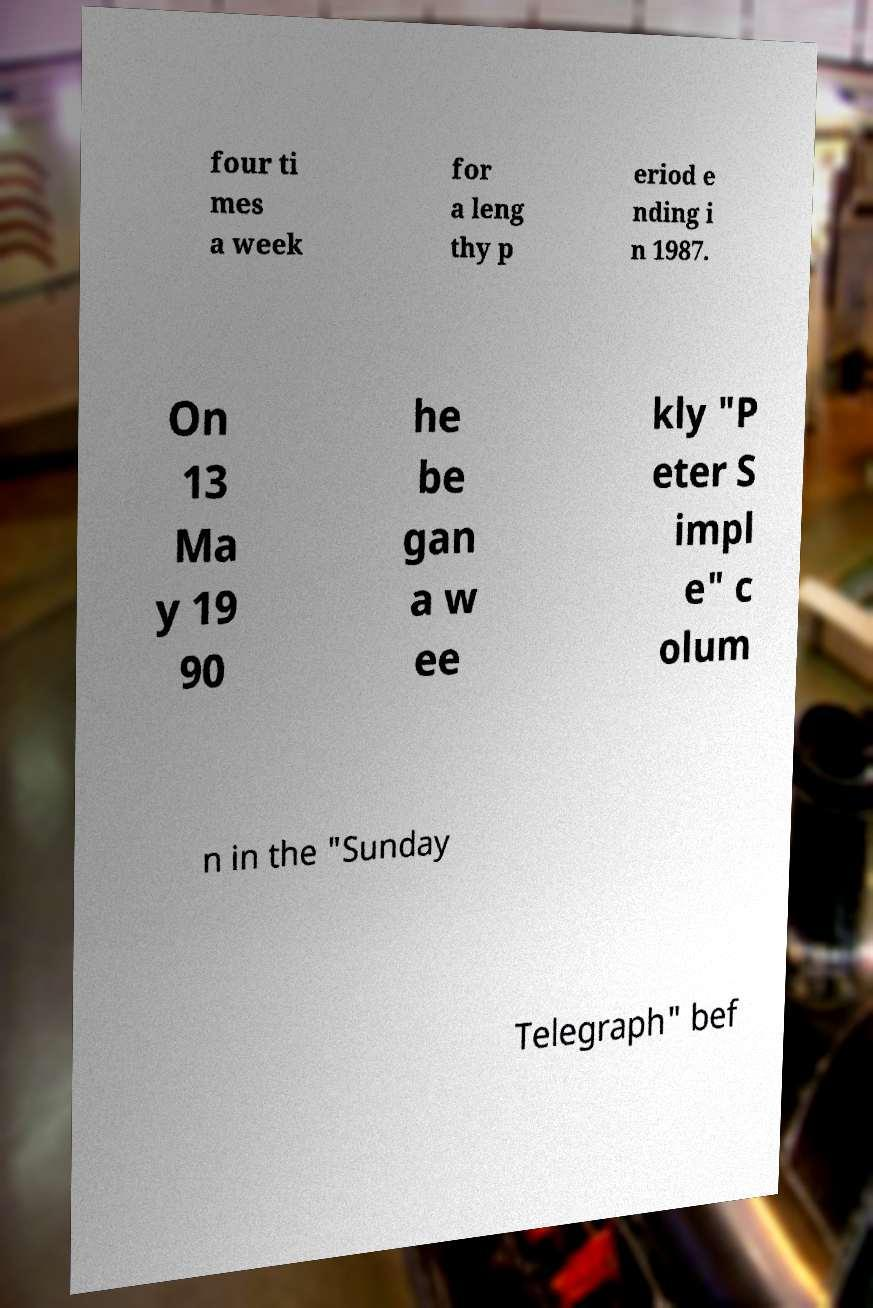Can you accurately transcribe the text from the provided image for me? four ti mes a week for a leng thy p eriod e nding i n 1987. On 13 Ma y 19 90 he be gan a w ee kly "P eter S impl e" c olum n in the "Sunday Telegraph" bef 